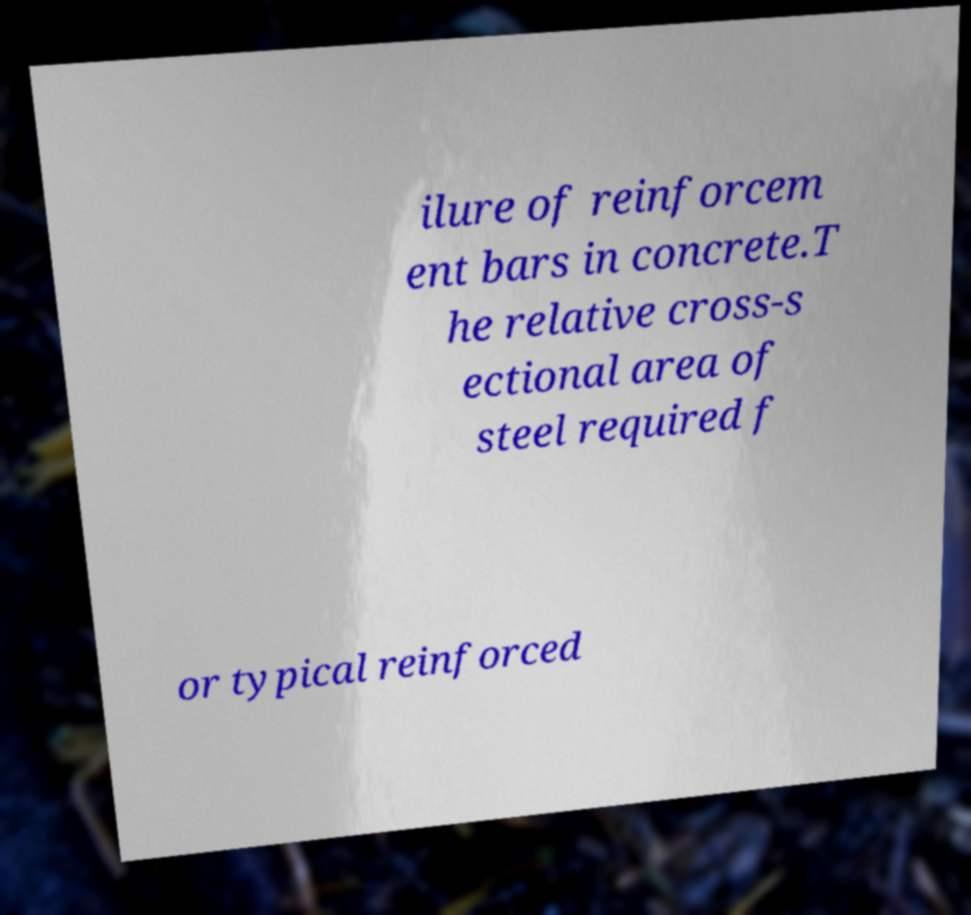Could you assist in decoding the text presented in this image and type it out clearly? ilure of reinforcem ent bars in concrete.T he relative cross-s ectional area of steel required f or typical reinforced 